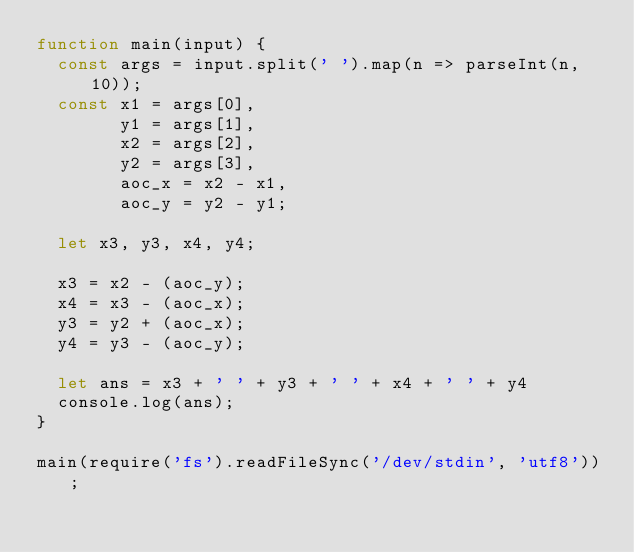<code> <loc_0><loc_0><loc_500><loc_500><_JavaScript_>function main(input) {
  const args = input.split(' ').map(n => parseInt(n, 10));
  const x1 = args[0],
        y1 = args[1],
    	x2 = args[2],
        y2 = args[3],
        aoc_x = x2 - x1,
        aoc_y = y2 - y1;
  
  let x3, y3, x4, y4;
  
  x3 = x2 - (aoc_y);
  x4 = x3 - (aoc_x);
  y3 = y2 + (aoc_x);
  y4 = y3 - (aoc_y);
  
  let ans = x3 + ' ' + y3 + ' ' + x4 + ' ' + y4
  console.log(ans);
}

main(require('fs').readFileSync('/dev/stdin', 'utf8'));</code> 